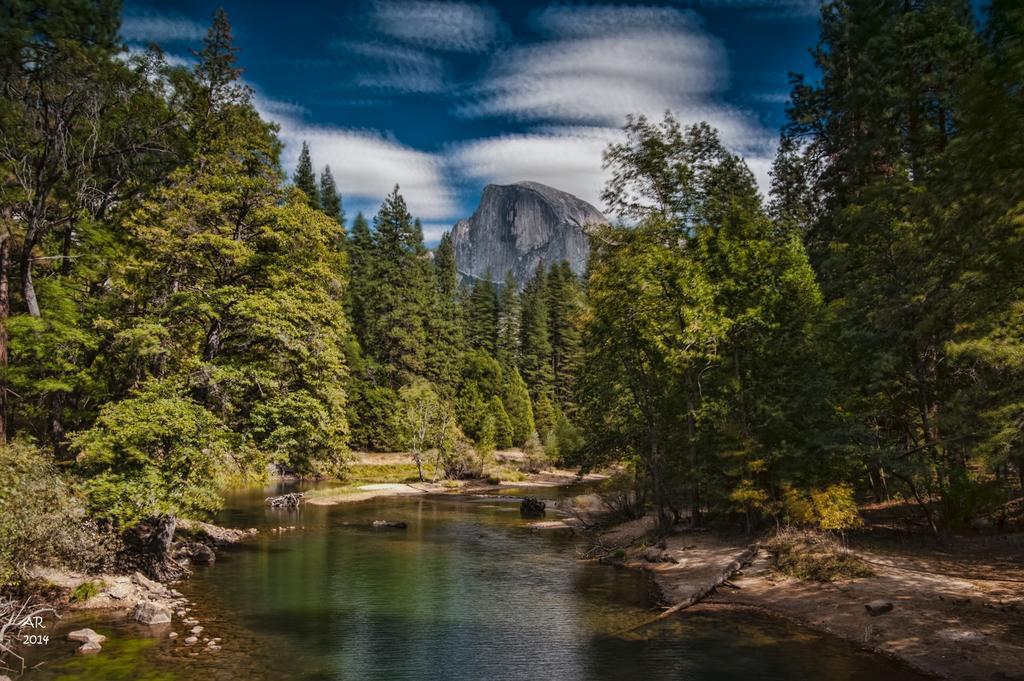Can you describe this image briefly? At the center of the image there is a pond. On the right and left side of the image there are some trees and mountains. In the background there is a sky. 